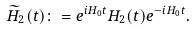<formula> <loc_0><loc_0><loc_500><loc_500>\widetilde { H } _ { 2 } ( t ) \colon = e ^ { i H _ { 0 } t } H _ { 2 } ( t ) e ^ { - i H _ { 0 } t } .</formula> 